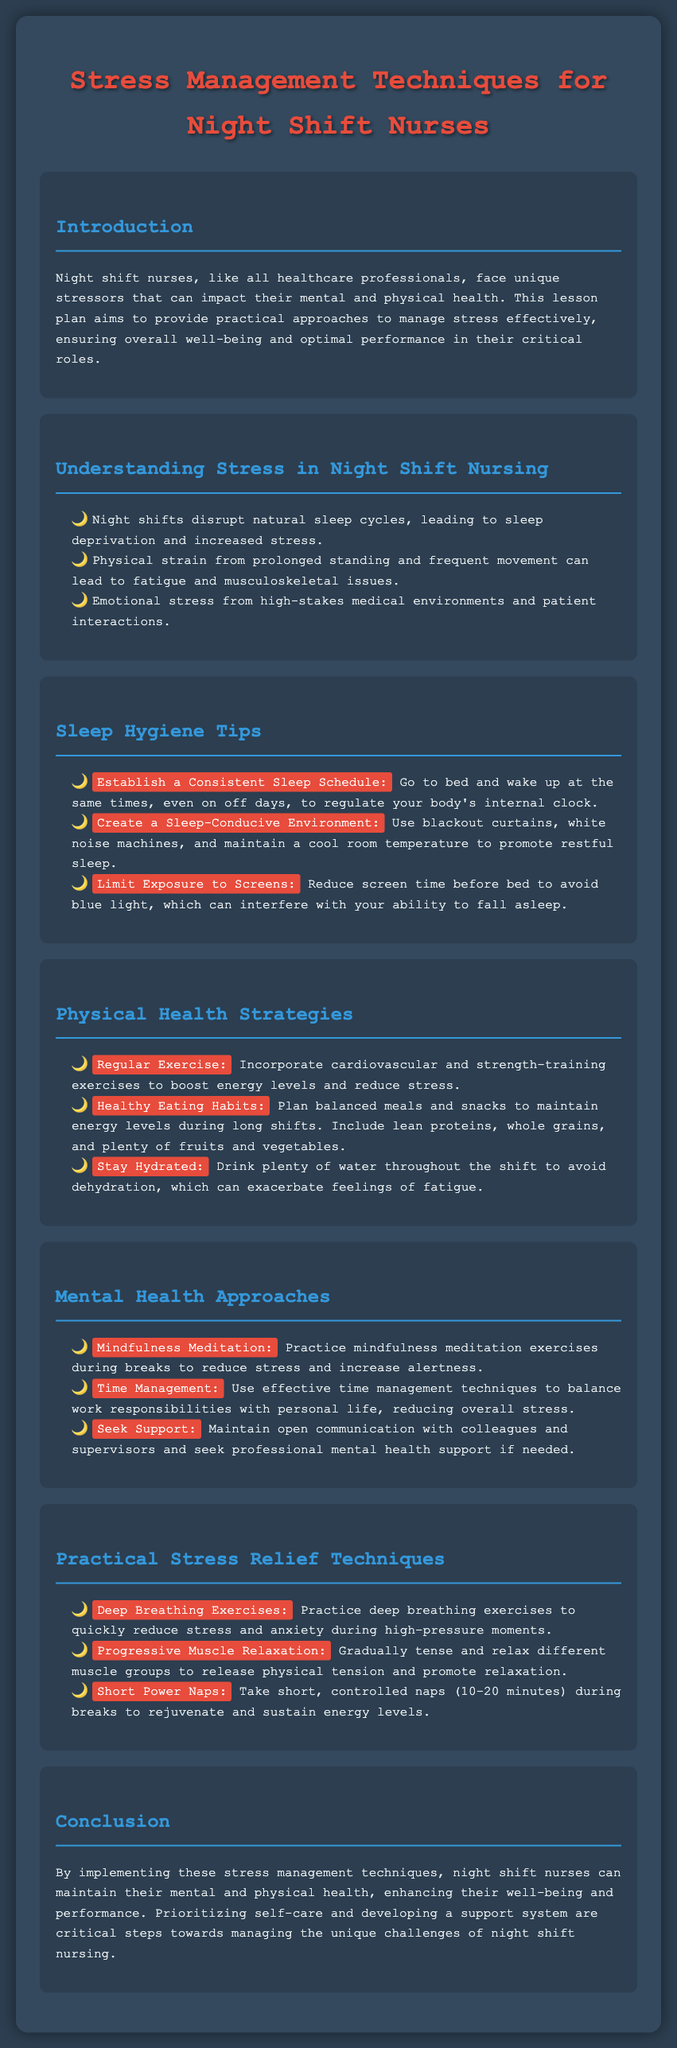what is the title of the lesson plan? The title is provided in the header of the document, which is "Stress Management Techniques for Night Shift Nurses."
Answer: Stress Management Techniques for Night Shift Nurses what is one of the unique stressors faced by night shift nurses? The document lists unique stressors such as "Sleep deprivation" that results from night shifts disrupting natural sleep cycles.
Answer: Sleep deprivation name a tip for improving sleep hygiene mentioned in the document. The document details several sleep hygiene tips, including "Establish a Consistent Sleep Schedule."
Answer: Establish a Consistent Sleep Schedule what is advised for maintaining hydration during shifts? The document emphasizes the importance of drinking water throughout the shift to avoid dehydration.
Answer: Drink plenty of water what is one mental health approach suggested for night shift nurses? The lesson plan suggests practicing "Mindfulness Meditation" as a way to reduce stress.
Answer: Mindfulness Meditation how long should short power naps be, according to the document? The document specifies the duration for short power naps as between "10-20 minutes."
Answer: 10-20 minutes what are the two main categories of health strategies discussed in the lesson plan? The document outlines "Physical Health Strategies" and "Mental Health Approaches."
Answer: Physical Health Strategies and Mental Health Approaches what is the purpose of the lesson plan? The document states that the aim is to provide practical approaches to manage stress effectively for night shift nurses.
Answer: Manage stress effectively 